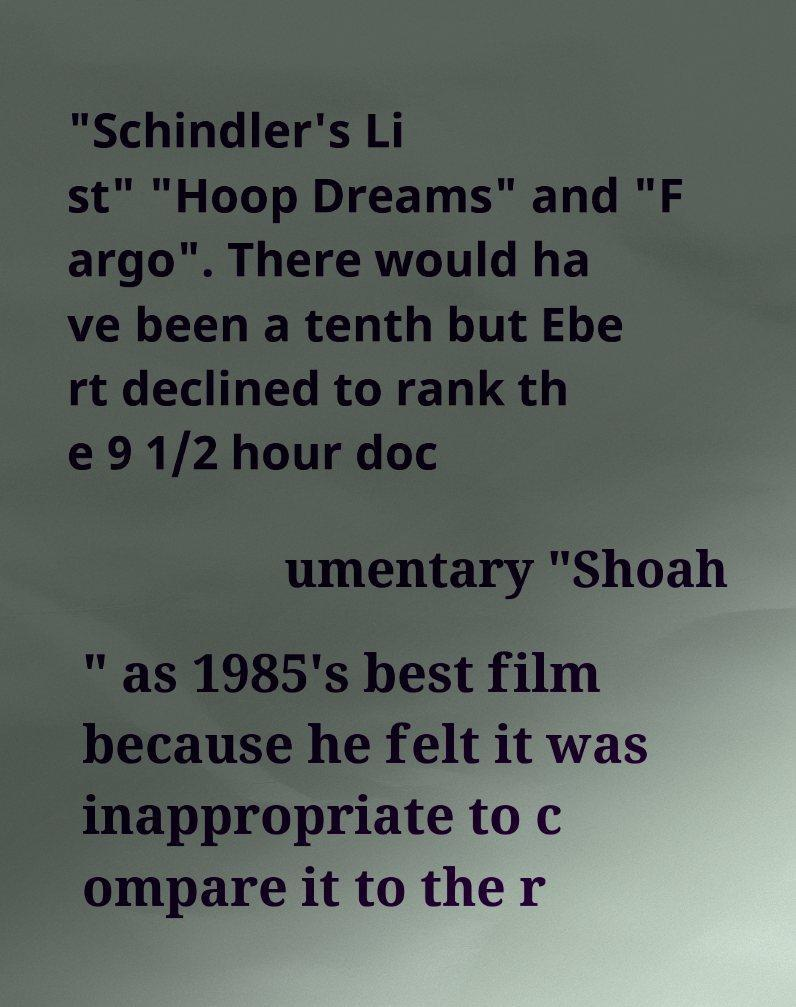What messages or text are displayed in this image? I need them in a readable, typed format. "Schindler's Li st" "Hoop Dreams" and "F argo". There would ha ve been a tenth but Ebe rt declined to rank th e 9 1/2 hour doc umentary "Shoah " as 1985's best film because he felt it was inappropriate to c ompare it to the r 